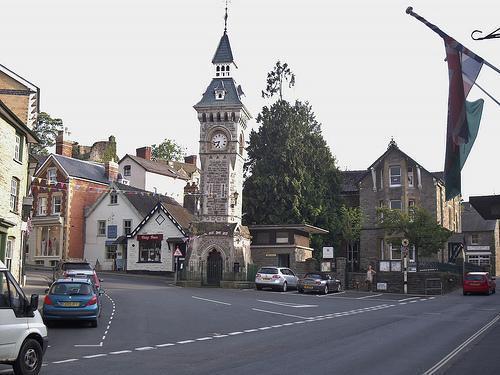How many cars are in photo?
Give a very brief answer. 6. 